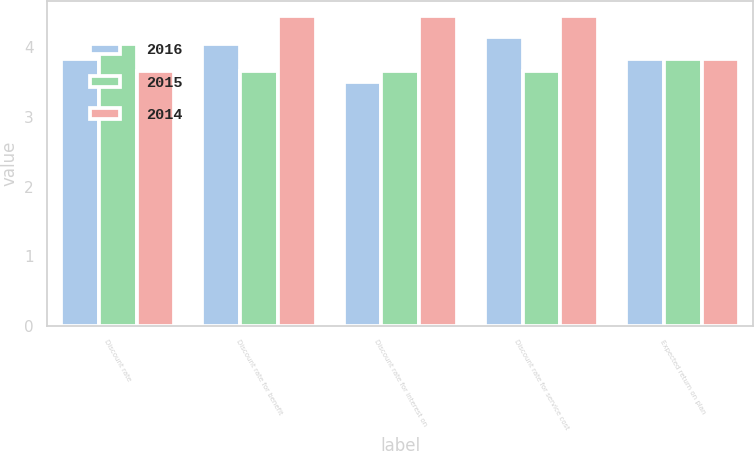Convert chart to OTSL. <chart><loc_0><loc_0><loc_500><loc_500><stacked_bar_chart><ecel><fcel>Discount rate<fcel>Discount rate for benefit<fcel>Discount rate for interest on<fcel>Discount rate for service cost<fcel>Expected return on plan<nl><fcel>2016<fcel>3.83<fcel>4.05<fcel>3.5<fcel>4.15<fcel>3.83<nl><fcel>2015<fcel>4.05<fcel>3.66<fcel>3.66<fcel>3.66<fcel>3.83<nl><fcel>2014<fcel>3.66<fcel>4.45<fcel>4.45<fcel>4.45<fcel>3.83<nl></chart> 